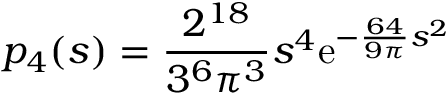<formula> <loc_0><loc_0><loc_500><loc_500>p _ { 4 } ( s ) = { \frac { 2 ^ { 1 8 } } { 3 ^ { 6 } \pi ^ { 3 } } } s ^ { 4 } e ^ { - { \frac { 6 4 } { 9 \pi } } s ^ { 2 } }</formula> 